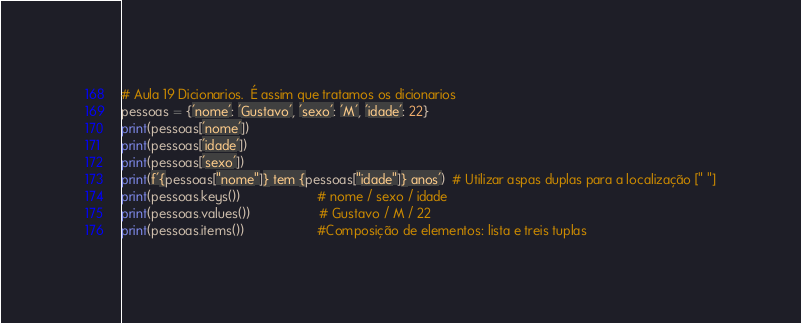<code> <loc_0><loc_0><loc_500><loc_500><_Python_># Aula 19 Dicionarios.  É assim que tratamos os dicionarios
pessoas = {'nome': 'Gustavo', 'sexo': 'M', 'idade': 22}
print(pessoas['nome'])
print(pessoas['idade'])
print(pessoas['sexo'])
print(f'{pessoas["nome"]} tem {pessoas["idade"]} anos')  # Utilizar aspas duplas para a localização [" "]
print(pessoas.keys())                     # nome / sexo / idade
print(pessoas.values())                   # Gustavo / M / 22
print(pessoas.items())                    #Composição de elementos: lista e treis tuplas


</code> 